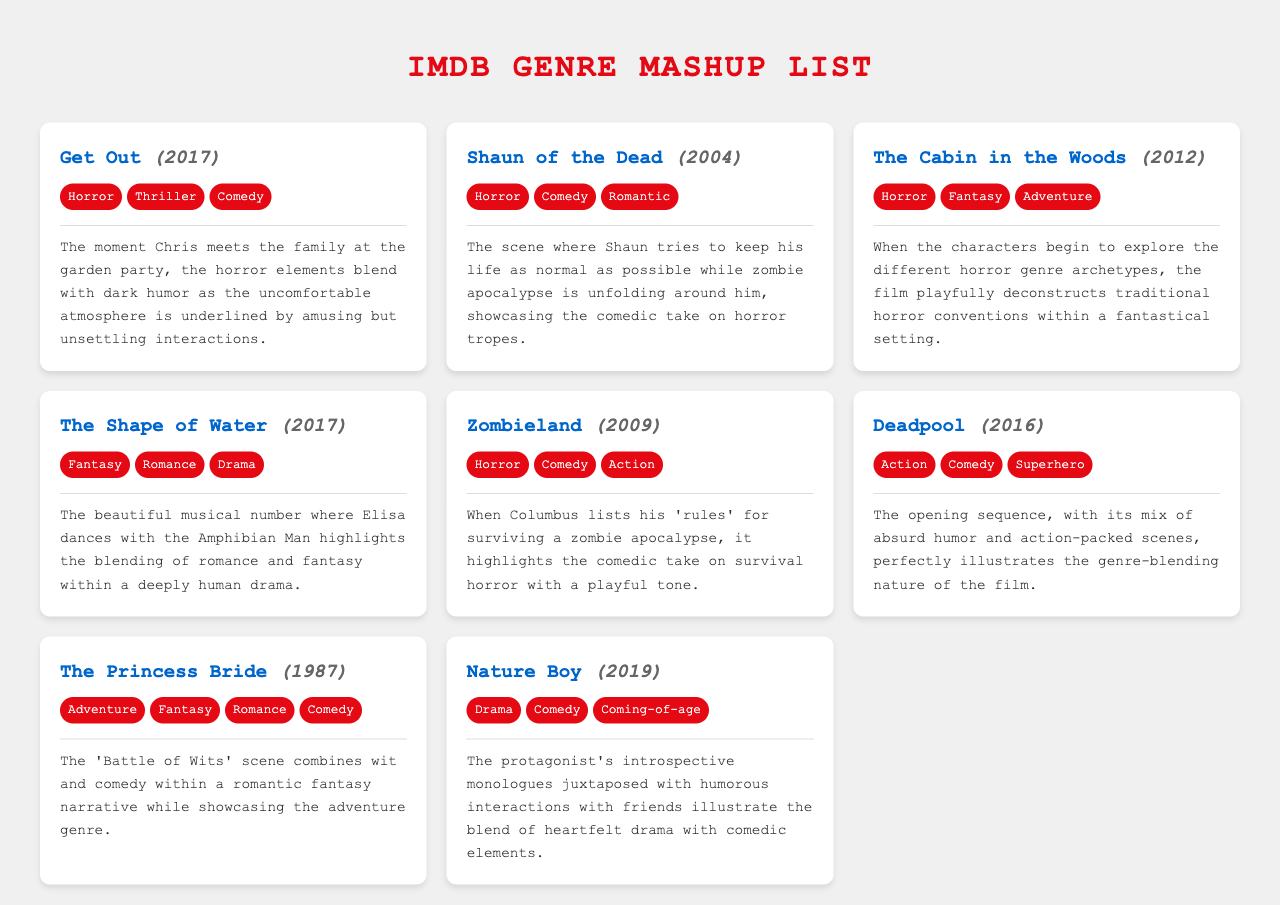What film was released in 2017 that blends horror, thriller, and comedy? The document lists "Get Out" as a film that was released in 2017 and blends horror, thriller, and comedy genres.
Answer: Get Out Which film features the scene where characters explore horror genre archetypes? The film "The Cabin in the Woods," from the document, has a scene where characters explore horror genre archetypes.
Answer: The Cabin in the Woods How many genres does "The Princess Bride" blend? The document indicates that "The Princess Bride" blends four genres: Adventure, Fantasy, Romance, and Comedy.
Answer: Four What type of scene in "Deadpool" illustrates its genre-blending nature? The opening sequence of "Deadpool" illustrates its genre-blending nature with a mix of absurd humor and action-packed scenes.
Answer: Opening sequence Which film combines heartfelt drama with comedic elements? The film "Nature Boy" is noted in the document for combining heartfelt drama with comedic elements through its protagonist’s interactions.
Answer: Nature Boy In what year was "Shaun of the Dead" released? The document states that "Shaun of the Dead" was released in 2004.
Answer: 2004 What genre combination is featured in "The Shape of Water"? According to the document, "The Shape of Water" features a combination of Fantasy, Romance, and Drama.
Answer: Fantasy, Romance, Drama Which film features a humorous survival list during a zombie apocalypse? "Zombieland" is the film noted for featuring a humorous survival list during a zombie apocalypse.
Answer: Zombieland 